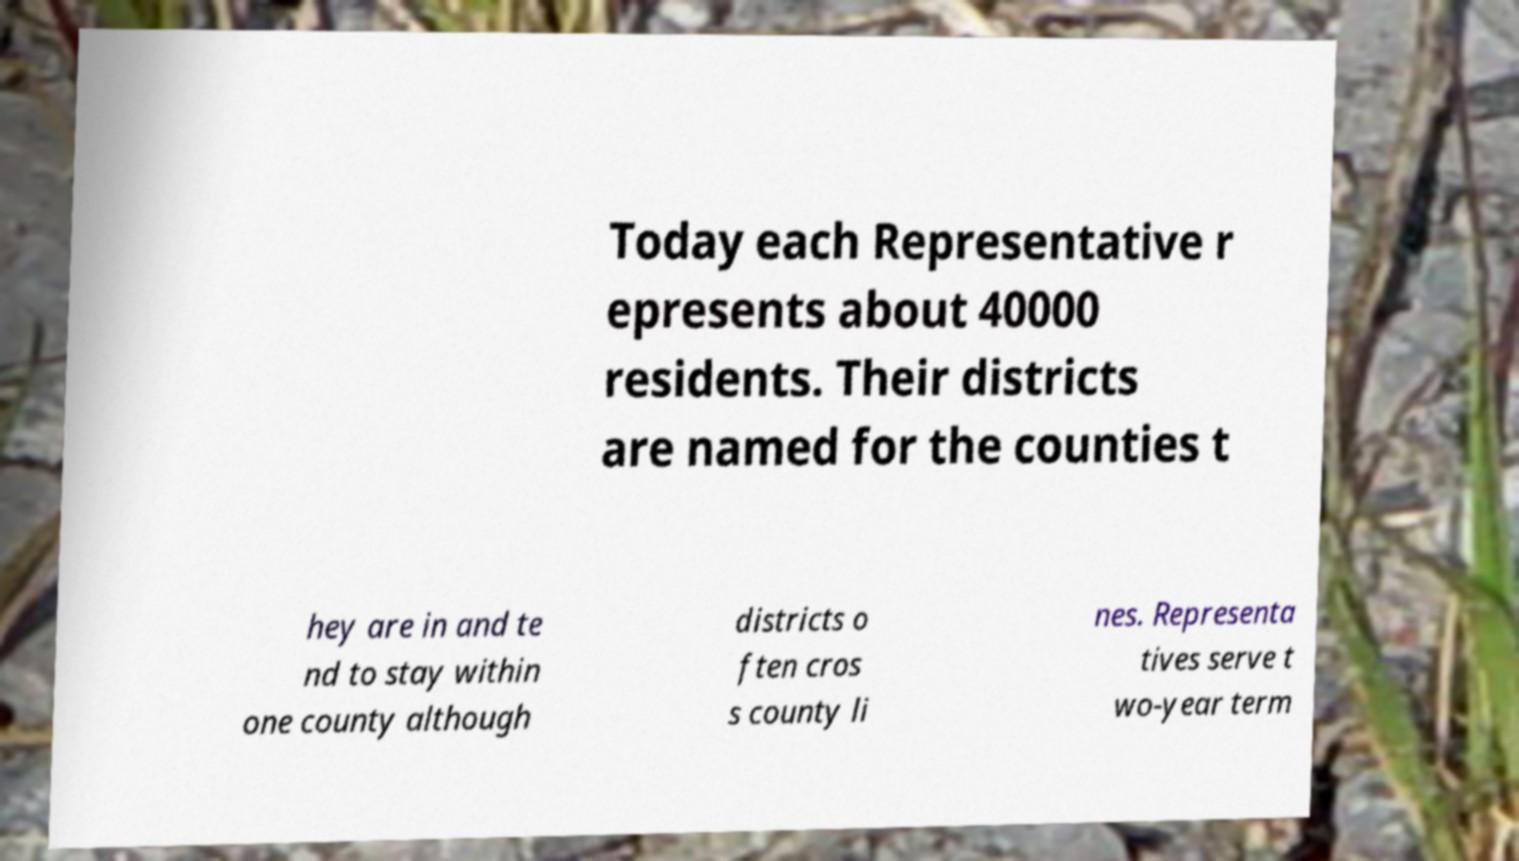Could you extract and type out the text from this image? Today each Representative r epresents about 40000 residents. Their districts are named for the counties t hey are in and te nd to stay within one county although districts o ften cros s county li nes. Representa tives serve t wo-year term 